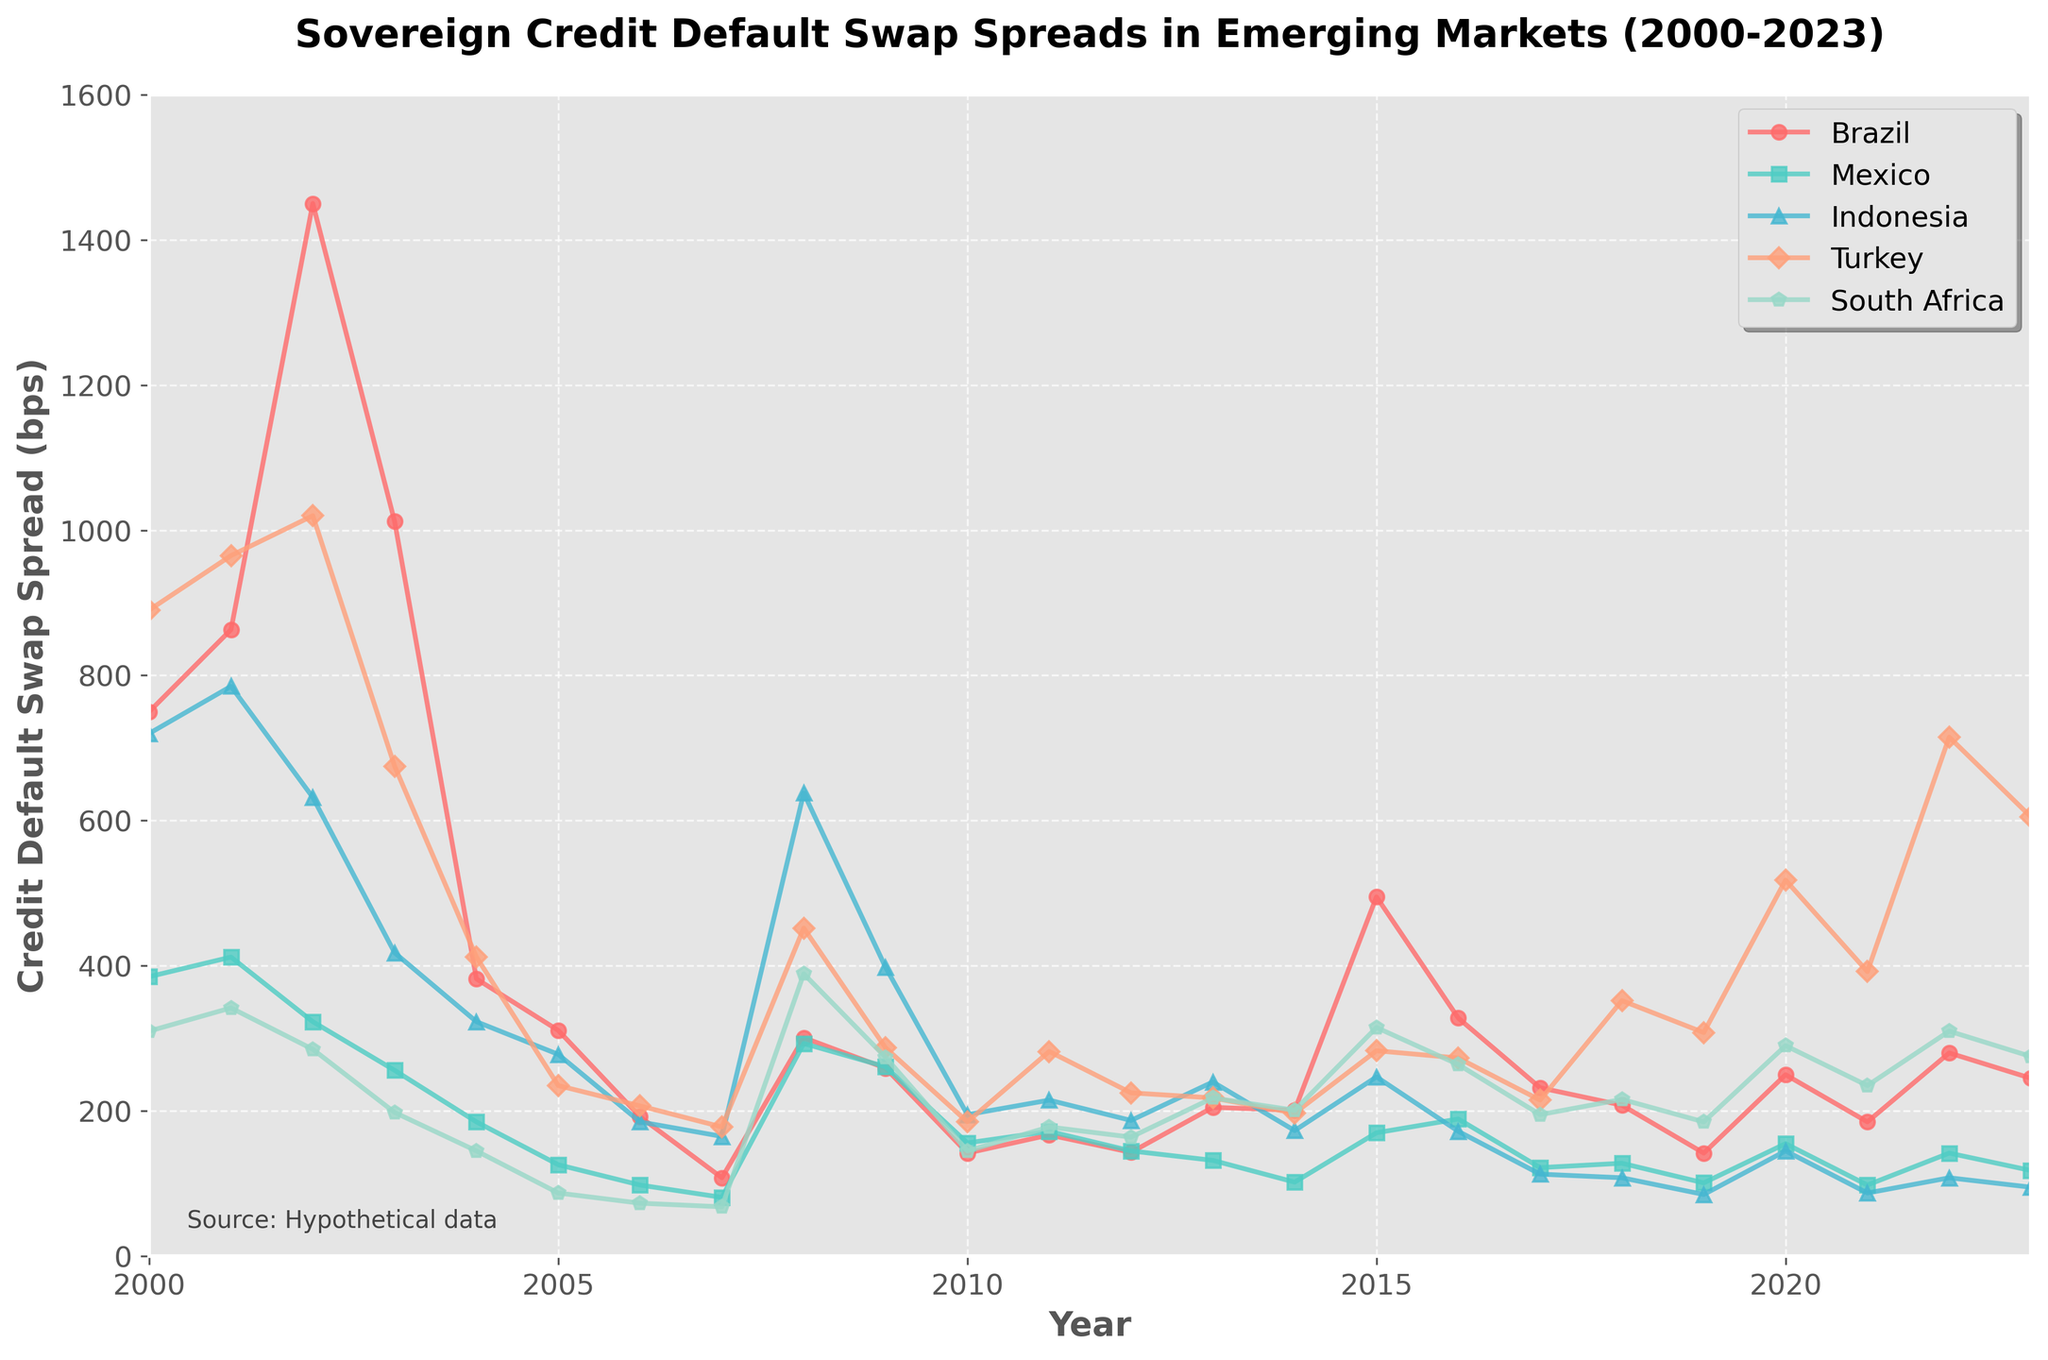What's the highest credit default swap spread for Brazil and in which year? Look at the line corresponding to Brazil (red line). The peak will be the highest point on this line. From the plot, this is around the year 2002 with approximately 1450 bps.
Answer: 1450 bps in 2002 Which country had the lowest credit default swap spread in 2017? Find the point for year 2017 for all countries and compare their values. Indonesia has the lowest spread for that year at approximately 113 bps.
Answer: Indonesia What was the average credit default swap spread for South Africa between 2015 and 2020? Identify the values for South Africa from 2015 to 2020: 315, 264, 195, 216, 185, 290. The average is the sum of these values divided by the number of years: (315 + 264 + 195 + 216 + 185 + 290) / 6 = 244.17 bps.
Answer: 244.17 bps Which two countries had a crossover in credit default swap spreads around 2008? Look at the intersections of the lines in the year 2008. Brazil and Indonesia's lines intersect around this point.
Answer: Brazil and Indonesia From 2009 to 2013, did Mexico's credit default swap spread ever exceed that of Turkey? Compare Mexico and Turkey’s credit default swap spreads from 2009 to 2013 by looking at the values for each year. Turkey's spreads were consistently higher than Mexico's spreads throughout these years.
Answer: No Which country experienced the largest increase in credit default swap spread from 2021 to 2022? Calculate the difference in credit default swap spreads between 2021 and 2022 for each country, then identify the country with the largest difference. Turkey increased from 392 to 715, which is the largest difference of 323 bps.
Answer: Turkey What is the overall trend of Mexico's credit default swap spread from 2000 to 2023? Observe the general direction of the line representing Mexico (green line). The spread generally decreases over time from 385 bps in 2000 to 118 bps in 2023.
Answer: Decreasing How often did Brazil's credit default swap spread fall below 200 bps between 2000 and 2023? Check the years when Brazil's spread falls below 200 bps: 2006, 2007, 2010, 2012, 2013, 2014, 2017, 2018, 2019, and 2021. Count these occurrences.
Answer: 10 times In which year did South Africa experience its highest credit default swap spread, and what was the value? Locate the highest point on the line for South Africa (purple line). This occurred in 2008 with a value of approximately 389 bps.
Answer: 2008, 389 bps Which country shows the most volatility in its credit default swap spreads from 2000 to 2023? Determine volatility by observing the amplitude of the fluctuations in each country's line. Brazil exhibits the most significant fluctuations between its peak (1450 bps) and trough (108 bps).
Answer: Brazil 